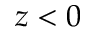Convert formula to latex. <formula><loc_0><loc_0><loc_500><loc_500>z < 0</formula> 